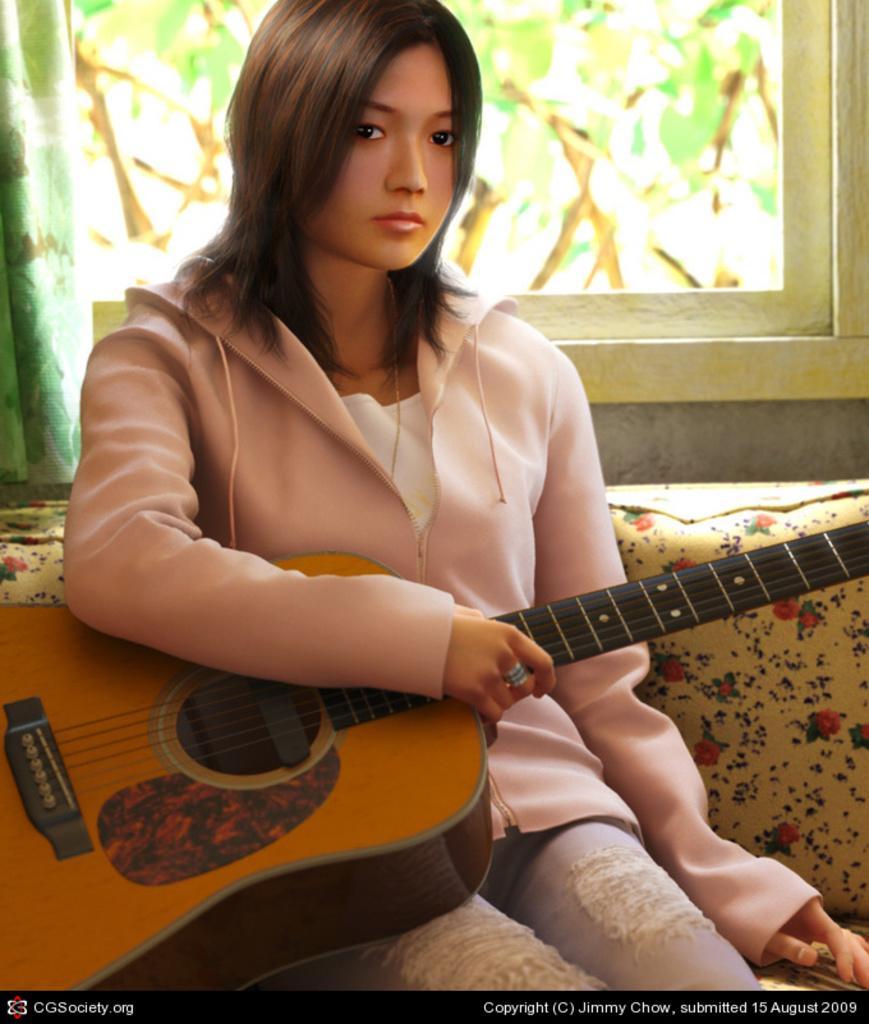Please provide a concise description of this image. A woman is sitting on the chair holding guitar in her hand. Behind her there is a window and a curtain. 